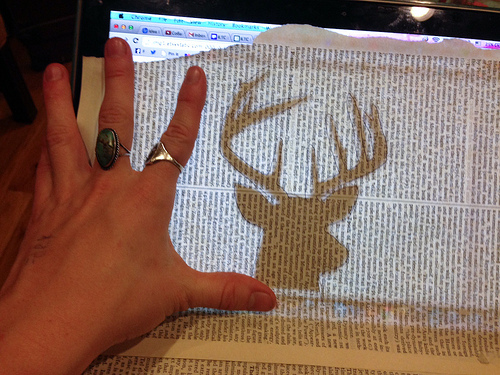<image>
Can you confirm if the deer is on the paper? Yes. Looking at the image, I can see the deer is positioned on top of the paper, with the paper providing support. 